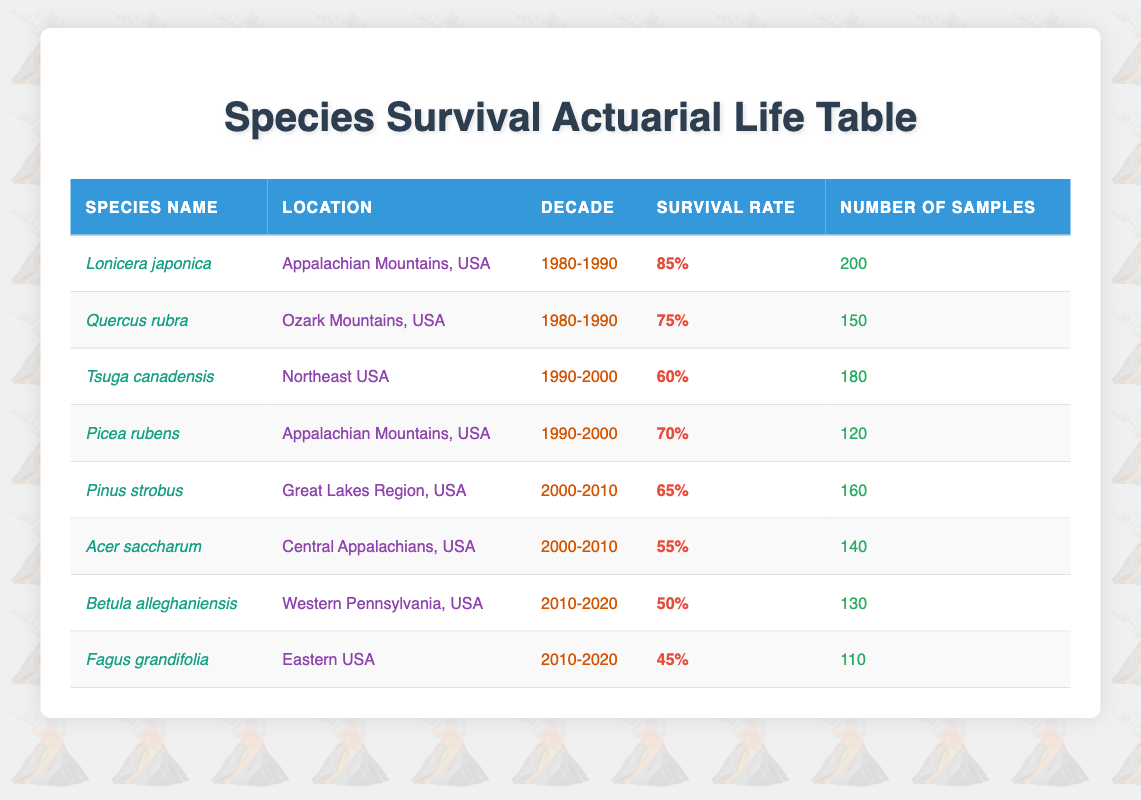What is the survival rate of Lonicera japonica in the 1980-1990 decade? The table shows that the survival rate for Lonicera japonica in the 1980-1990 decade is listed as 85%.
Answer: 85% How many samples were collected for Acer saccharum in the 2000-2010 decade? According to the table, the number of samples collected for Acer saccharum in the 2000-2010 decade is 140.
Answer: 140 Which species had the highest survival rate, and what was that rate? By reviewing the survival rates in the table, Lonicera japonica has the highest survival rate of 85% compared to others.
Answer: Lonicera japonica; 85% Is the survival rate of Fagus grandifolia higher than that of Tsuga canadensis? Yes, the survival rate for Fagus grandifolia is 45%, while Tsuga canadensis has a survival rate of 60%, so Fagus grandifolia's rate is not higher.
Answer: No What is the average survival rate for species in the 2000-2010 decade? The survival rates for the 2000-2010 decade are 65% for Pinus strobus and 55% for Acer saccharum. The average can be calculated as (65 + 55) / 2, which equals 60%.
Answer: 60% How many total samples were taken across all species in the 1990-2000 decade? For the 1990-2000 decade, the species Tsuga canadensis had 180 samples and Picea rubens had 120 samples. Adding these gives a total of 180 + 120 = 300 samples.
Answer: 300 Did more species have a survival rate below 60% during the 2010-2020 decade compared to the 2000-2010 decade? In the 2010-2020 decade, there are two species (Betula alleghaniensis at 50% and Fagus grandifolia at 45% < 60%). In the 2000-2010 decade, only Acer saccharum at 55% is below 60%. Hence, more species had rates below 60% in the 2010-2020 decade.
Answer: Yes Which species had the lowest survival rate, and where was it located? The table indicates that Fagus grandifolia had the lowest survival rate of 45%, and it is located in Eastern USA.
Answer: Fagus grandifolia; Eastern USA 